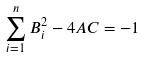<formula> <loc_0><loc_0><loc_500><loc_500>\sum _ { i = 1 } ^ { n } B _ { i } ^ { 2 } - 4 A C = - 1</formula> 